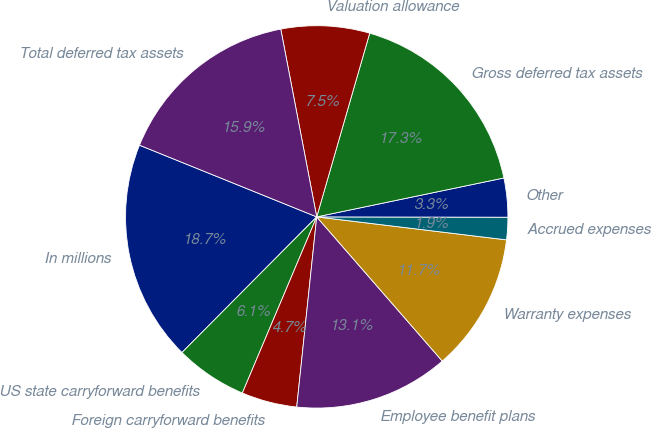<chart> <loc_0><loc_0><loc_500><loc_500><pie_chart><fcel>In millions<fcel>US state carryforward benefits<fcel>Foreign carryforward benefits<fcel>Employee benefit plans<fcel>Warranty expenses<fcel>Accrued expenses<fcel>Other<fcel>Gross deferred tax assets<fcel>Valuation allowance<fcel>Total deferred tax assets<nl><fcel>18.67%<fcel>6.09%<fcel>4.69%<fcel>13.07%<fcel>11.68%<fcel>1.89%<fcel>3.29%<fcel>17.27%<fcel>7.48%<fcel>15.87%<nl></chart> 